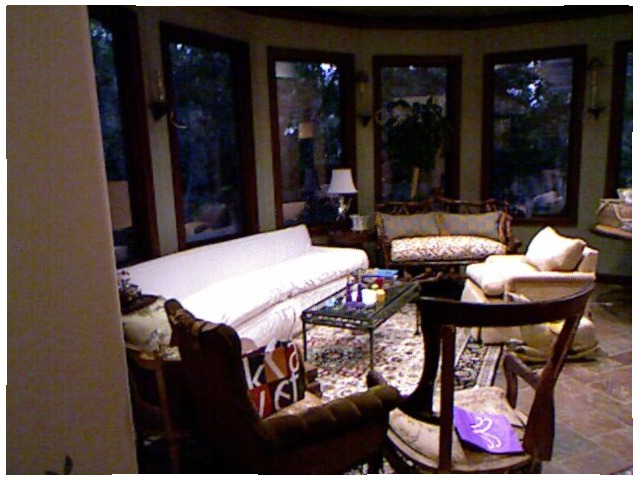<image>
Is the table in front of the sofa? Yes. The table is positioned in front of the sofa, appearing closer to the camera viewpoint. Where is the basket in relation to the armchair? Is it on the armchair? Yes. Looking at the image, I can see the basket is positioned on top of the armchair, with the armchair providing support. 